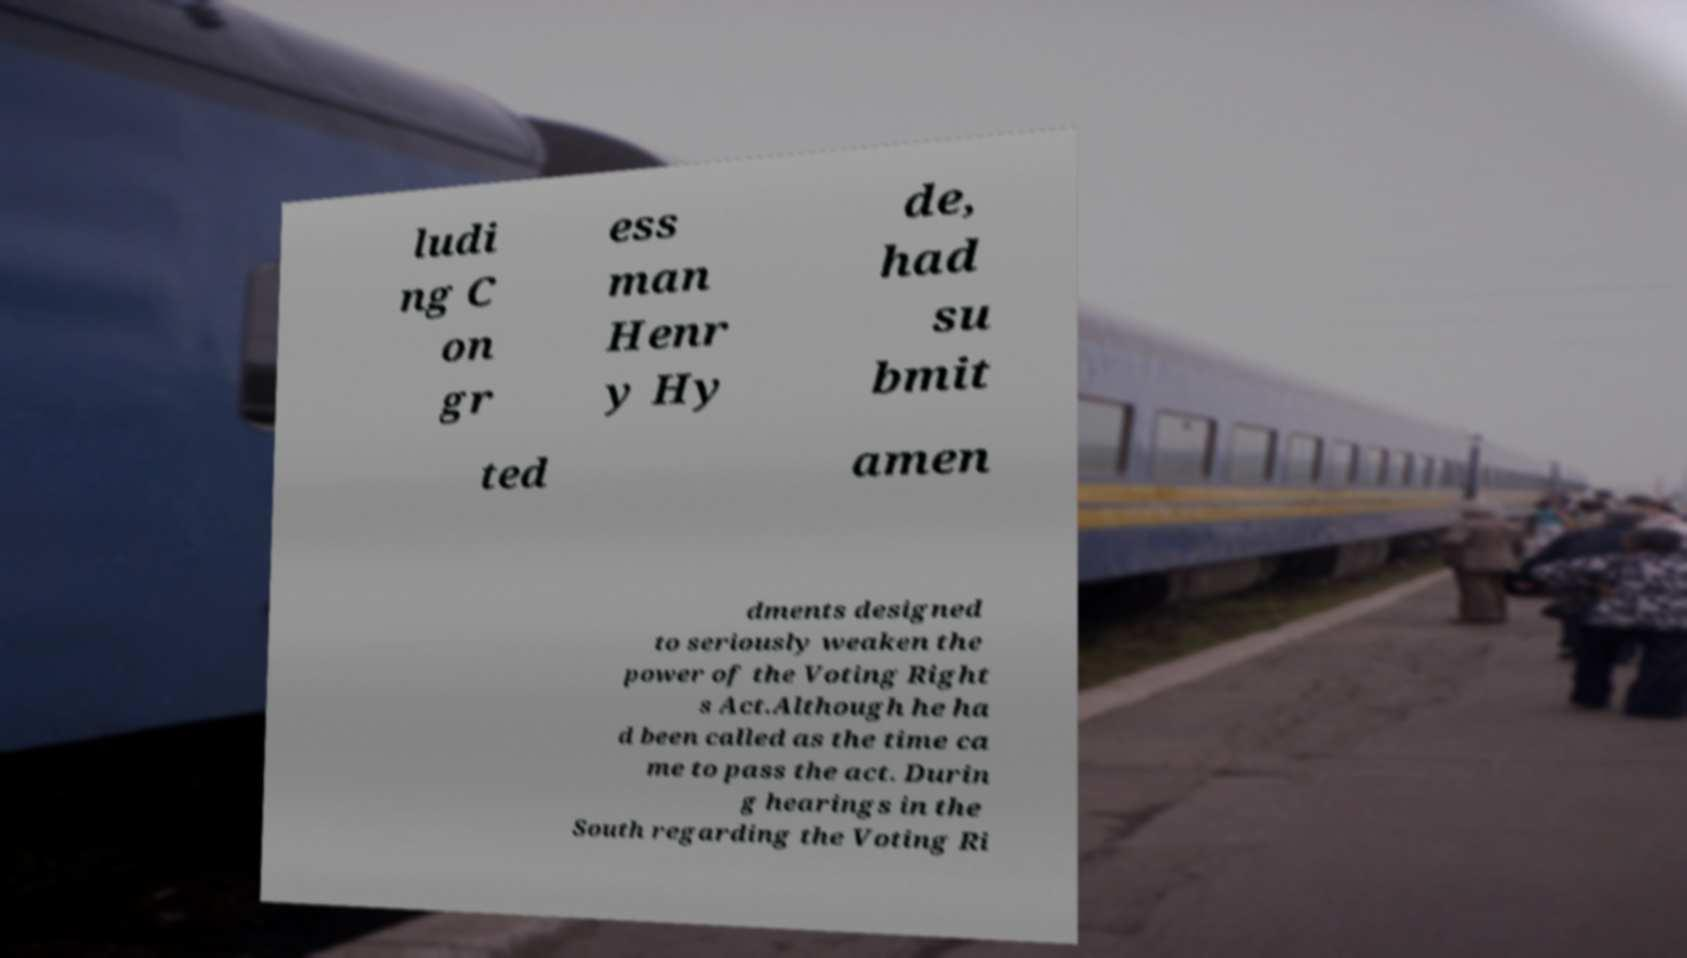Can you accurately transcribe the text from the provided image for me? ludi ng C on gr ess man Henr y Hy de, had su bmit ted amen dments designed to seriously weaken the power of the Voting Right s Act.Although he ha d been called as the time ca me to pass the act. Durin g hearings in the South regarding the Voting Ri 